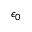Convert formula to latex. <formula><loc_0><loc_0><loc_500><loc_500>\epsilon _ { 0 }</formula> 